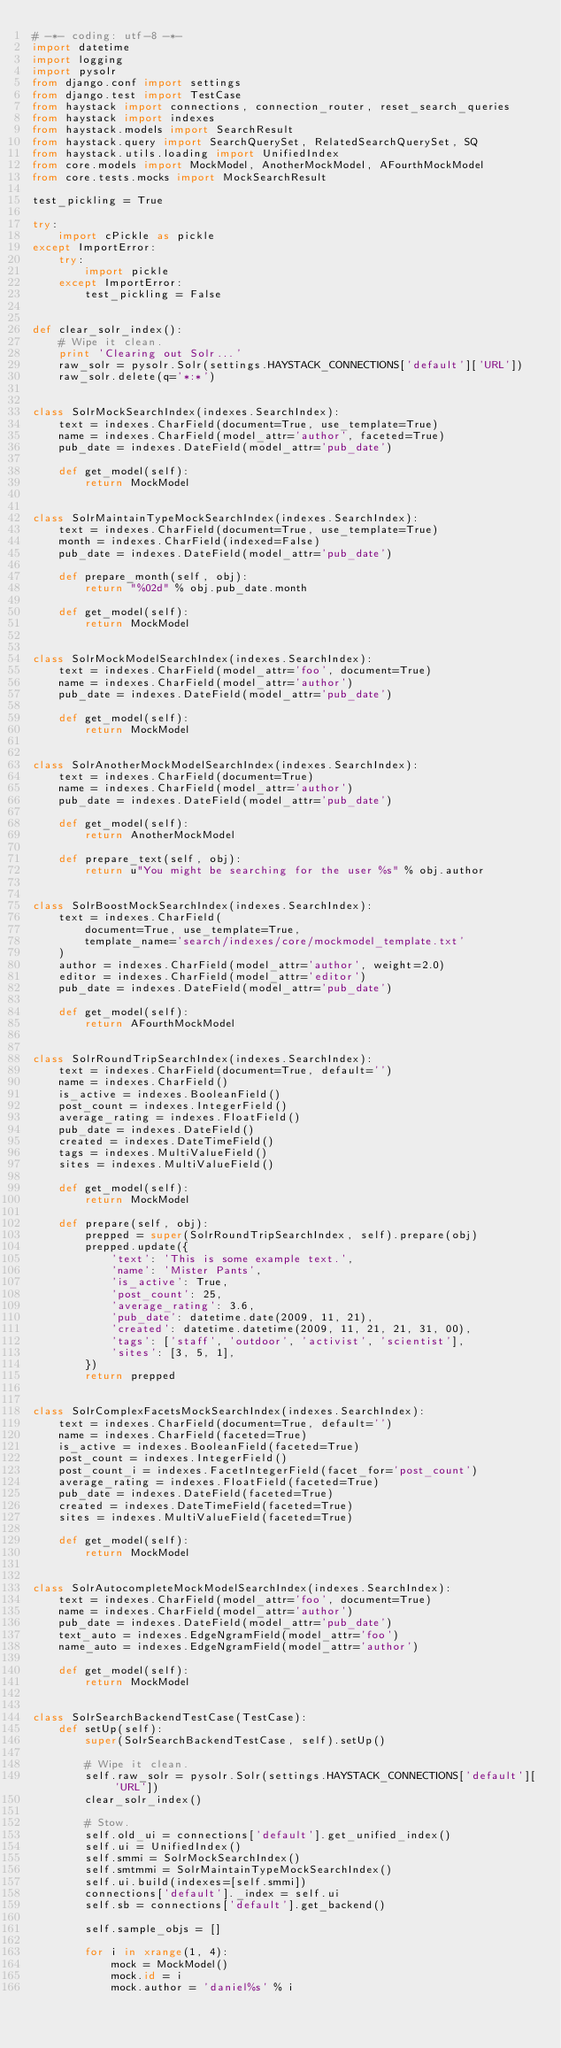<code> <loc_0><loc_0><loc_500><loc_500><_Python_># -*- coding: utf-8 -*-
import datetime
import logging
import pysolr
from django.conf import settings
from django.test import TestCase
from haystack import connections, connection_router, reset_search_queries
from haystack import indexes
from haystack.models import SearchResult
from haystack.query import SearchQuerySet, RelatedSearchQuerySet, SQ
from haystack.utils.loading import UnifiedIndex
from core.models import MockModel, AnotherMockModel, AFourthMockModel
from core.tests.mocks import MockSearchResult

test_pickling = True

try:
    import cPickle as pickle
except ImportError:
    try:
        import pickle
    except ImportError:
        test_pickling = False


def clear_solr_index():
    # Wipe it clean.
    print 'Clearing out Solr...'
    raw_solr = pysolr.Solr(settings.HAYSTACK_CONNECTIONS['default']['URL'])
    raw_solr.delete(q='*:*')


class SolrMockSearchIndex(indexes.SearchIndex):
    text = indexes.CharField(document=True, use_template=True)
    name = indexes.CharField(model_attr='author', faceted=True)
    pub_date = indexes.DateField(model_attr='pub_date')
    
    def get_model(self):
        return MockModel


class SolrMaintainTypeMockSearchIndex(indexes.SearchIndex):
    text = indexes.CharField(document=True, use_template=True)
    month = indexes.CharField(indexed=False)
    pub_date = indexes.DateField(model_attr='pub_date')
    
    def prepare_month(self, obj):
        return "%02d" % obj.pub_date.month
    
    def get_model(self):
        return MockModel


class SolrMockModelSearchIndex(indexes.SearchIndex):
    text = indexes.CharField(model_attr='foo', document=True)
    name = indexes.CharField(model_attr='author')
    pub_date = indexes.DateField(model_attr='pub_date')
    
    def get_model(self):
        return MockModel


class SolrAnotherMockModelSearchIndex(indexes.SearchIndex):
    text = indexes.CharField(document=True)
    name = indexes.CharField(model_attr='author')
    pub_date = indexes.DateField(model_attr='pub_date')
    
    def get_model(self):
        return AnotherMockModel
    
    def prepare_text(self, obj):
        return u"You might be searching for the user %s" % obj.author


class SolrBoostMockSearchIndex(indexes.SearchIndex):
    text = indexes.CharField(
        document=True, use_template=True,
        template_name='search/indexes/core/mockmodel_template.txt'
    )
    author = indexes.CharField(model_attr='author', weight=2.0)
    editor = indexes.CharField(model_attr='editor')
    pub_date = indexes.DateField(model_attr='pub_date')
    
    def get_model(self):
        return AFourthMockModel


class SolrRoundTripSearchIndex(indexes.SearchIndex):
    text = indexes.CharField(document=True, default='')
    name = indexes.CharField()
    is_active = indexes.BooleanField()
    post_count = indexes.IntegerField()
    average_rating = indexes.FloatField()
    pub_date = indexes.DateField()
    created = indexes.DateTimeField()
    tags = indexes.MultiValueField()
    sites = indexes.MultiValueField()
    
    def get_model(self):
        return MockModel
    
    def prepare(self, obj):
        prepped = super(SolrRoundTripSearchIndex, self).prepare(obj)
        prepped.update({
            'text': 'This is some example text.',
            'name': 'Mister Pants',
            'is_active': True,
            'post_count': 25,
            'average_rating': 3.6,
            'pub_date': datetime.date(2009, 11, 21),
            'created': datetime.datetime(2009, 11, 21, 21, 31, 00),
            'tags': ['staff', 'outdoor', 'activist', 'scientist'],
            'sites': [3, 5, 1],
        })
        return prepped


class SolrComplexFacetsMockSearchIndex(indexes.SearchIndex):
    text = indexes.CharField(document=True, default='')
    name = indexes.CharField(faceted=True)
    is_active = indexes.BooleanField(faceted=True)
    post_count = indexes.IntegerField()
    post_count_i = indexes.FacetIntegerField(facet_for='post_count')
    average_rating = indexes.FloatField(faceted=True)
    pub_date = indexes.DateField(faceted=True)
    created = indexes.DateTimeField(faceted=True)
    sites = indexes.MultiValueField(faceted=True)
    
    def get_model(self):
        return MockModel


class SolrAutocompleteMockModelSearchIndex(indexes.SearchIndex):
    text = indexes.CharField(model_attr='foo', document=True)
    name = indexes.CharField(model_attr='author')
    pub_date = indexes.DateField(model_attr='pub_date')
    text_auto = indexes.EdgeNgramField(model_attr='foo')
    name_auto = indexes.EdgeNgramField(model_attr='author')
    
    def get_model(self):
        return MockModel


class SolrSearchBackendTestCase(TestCase):
    def setUp(self):
        super(SolrSearchBackendTestCase, self).setUp()
        
        # Wipe it clean.
        self.raw_solr = pysolr.Solr(settings.HAYSTACK_CONNECTIONS['default']['URL'])
        clear_solr_index()
        
        # Stow.
        self.old_ui = connections['default'].get_unified_index()
        self.ui = UnifiedIndex()
        self.smmi = SolrMockSearchIndex()
        self.smtmmi = SolrMaintainTypeMockSearchIndex()
        self.ui.build(indexes=[self.smmi])
        connections['default']._index = self.ui
        self.sb = connections['default'].get_backend()
        
        self.sample_objs = []
        
        for i in xrange(1, 4):
            mock = MockModel()
            mock.id = i
            mock.author = 'daniel%s' % i</code> 